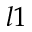Convert formula to latex. <formula><loc_0><loc_0><loc_500><loc_500>l 1</formula> 